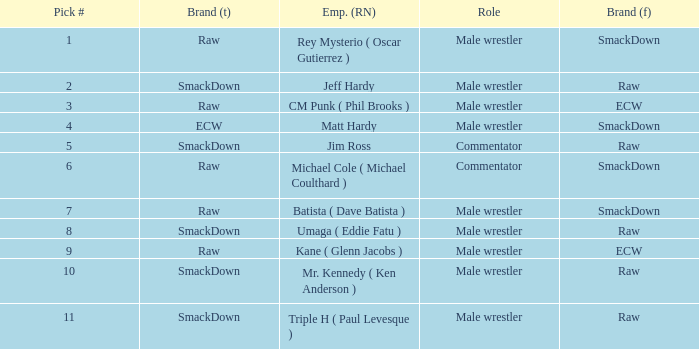What is the real name of the Pick # that is greater than 9? Mr. Kennedy ( Ken Anderson ), Triple H ( Paul Levesque ). Could you parse the entire table as a dict? {'header': ['Pick #', 'Brand (t)', 'Emp. (RN)', 'Role', 'Brand (f)'], 'rows': [['1', 'Raw', 'Rey Mysterio ( Oscar Gutierrez )', 'Male wrestler', 'SmackDown'], ['2', 'SmackDown', 'Jeff Hardy', 'Male wrestler', 'Raw'], ['3', 'Raw', 'CM Punk ( Phil Brooks )', 'Male wrestler', 'ECW'], ['4', 'ECW', 'Matt Hardy', 'Male wrestler', 'SmackDown'], ['5', 'SmackDown', 'Jim Ross', 'Commentator', 'Raw'], ['6', 'Raw', 'Michael Cole ( Michael Coulthard )', 'Commentator', 'SmackDown'], ['7', 'Raw', 'Batista ( Dave Batista )', 'Male wrestler', 'SmackDown'], ['8', 'SmackDown', 'Umaga ( Eddie Fatu )', 'Male wrestler', 'Raw'], ['9', 'Raw', 'Kane ( Glenn Jacobs )', 'Male wrestler', 'ECW'], ['10', 'SmackDown', 'Mr. Kennedy ( Ken Anderson )', 'Male wrestler', 'Raw'], ['11', 'SmackDown', 'Triple H ( Paul Levesque )', 'Male wrestler', 'Raw']]} 